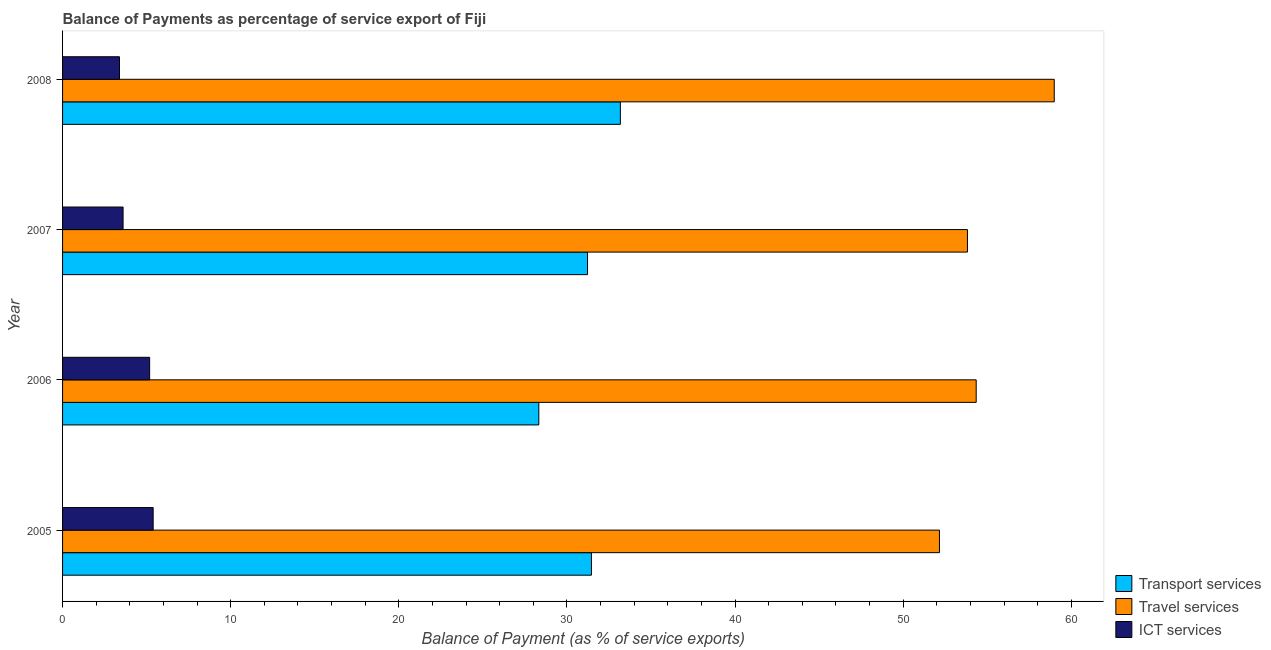How many different coloured bars are there?
Ensure brevity in your answer.  3. How many groups of bars are there?
Make the answer very short. 4. Are the number of bars per tick equal to the number of legend labels?
Provide a succinct answer. Yes. Are the number of bars on each tick of the Y-axis equal?
Offer a very short reply. Yes. What is the label of the 3rd group of bars from the top?
Your answer should be compact. 2006. In how many cases, is the number of bars for a given year not equal to the number of legend labels?
Keep it short and to the point. 0. What is the balance of payment of travel services in 2008?
Give a very brief answer. 58.98. Across all years, what is the maximum balance of payment of ict services?
Give a very brief answer. 5.39. Across all years, what is the minimum balance of payment of ict services?
Your response must be concise. 3.39. In which year was the balance of payment of travel services maximum?
Give a very brief answer. 2008. What is the total balance of payment of transport services in the graph?
Provide a short and direct response. 124.18. What is the difference between the balance of payment of transport services in 2005 and that in 2008?
Provide a succinct answer. -1.72. What is the difference between the balance of payment of transport services in 2006 and the balance of payment of ict services in 2008?
Make the answer very short. 24.94. What is the average balance of payment of ict services per year?
Your answer should be very brief. 4.39. In the year 2006, what is the difference between the balance of payment of travel services and balance of payment of ict services?
Provide a short and direct response. 49.16. In how many years, is the balance of payment of ict services greater than 32 %?
Your answer should be very brief. 0. What is the ratio of the balance of payment of transport services in 2005 to that in 2006?
Your answer should be compact. 1.11. Is the difference between the balance of payment of travel services in 2005 and 2007 greater than the difference between the balance of payment of ict services in 2005 and 2007?
Make the answer very short. No. What is the difference between the highest and the second highest balance of payment of ict services?
Your answer should be very brief. 0.21. What is the difference between the highest and the lowest balance of payment of travel services?
Keep it short and to the point. 6.83. In how many years, is the balance of payment of transport services greater than the average balance of payment of transport services taken over all years?
Offer a terse response. 3. Is the sum of the balance of payment of ict services in 2006 and 2008 greater than the maximum balance of payment of transport services across all years?
Make the answer very short. No. What does the 1st bar from the top in 2005 represents?
Keep it short and to the point. ICT services. What does the 2nd bar from the bottom in 2006 represents?
Offer a very short reply. Travel services. How many bars are there?
Offer a terse response. 12. Are all the bars in the graph horizontal?
Your answer should be compact. Yes. How many years are there in the graph?
Give a very brief answer. 4. Are the values on the major ticks of X-axis written in scientific E-notation?
Provide a succinct answer. No. Where does the legend appear in the graph?
Make the answer very short. Bottom right. How many legend labels are there?
Give a very brief answer. 3. What is the title of the graph?
Your answer should be compact. Balance of Payments as percentage of service export of Fiji. What is the label or title of the X-axis?
Provide a short and direct response. Balance of Payment (as % of service exports). What is the label or title of the Y-axis?
Keep it short and to the point. Year. What is the Balance of Payment (as % of service exports) in Transport services in 2005?
Offer a terse response. 31.45. What is the Balance of Payment (as % of service exports) of Travel services in 2005?
Your response must be concise. 52.15. What is the Balance of Payment (as % of service exports) of ICT services in 2005?
Keep it short and to the point. 5.39. What is the Balance of Payment (as % of service exports) in Transport services in 2006?
Keep it short and to the point. 28.33. What is the Balance of Payment (as % of service exports) of Travel services in 2006?
Offer a very short reply. 54.34. What is the Balance of Payment (as % of service exports) of ICT services in 2006?
Keep it short and to the point. 5.18. What is the Balance of Payment (as % of service exports) in Transport services in 2007?
Give a very brief answer. 31.22. What is the Balance of Payment (as % of service exports) of Travel services in 2007?
Keep it short and to the point. 53.82. What is the Balance of Payment (as % of service exports) in ICT services in 2007?
Ensure brevity in your answer.  3.6. What is the Balance of Payment (as % of service exports) of Transport services in 2008?
Make the answer very short. 33.18. What is the Balance of Payment (as % of service exports) of Travel services in 2008?
Your response must be concise. 58.98. What is the Balance of Payment (as % of service exports) in ICT services in 2008?
Make the answer very short. 3.39. Across all years, what is the maximum Balance of Payment (as % of service exports) in Transport services?
Keep it short and to the point. 33.18. Across all years, what is the maximum Balance of Payment (as % of service exports) in Travel services?
Your answer should be compact. 58.98. Across all years, what is the maximum Balance of Payment (as % of service exports) of ICT services?
Provide a succinct answer. 5.39. Across all years, what is the minimum Balance of Payment (as % of service exports) of Transport services?
Give a very brief answer. 28.33. Across all years, what is the minimum Balance of Payment (as % of service exports) in Travel services?
Make the answer very short. 52.15. Across all years, what is the minimum Balance of Payment (as % of service exports) of ICT services?
Your answer should be compact. 3.39. What is the total Balance of Payment (as % of service exports) of Transport services in the graph?
Give a very brief answer. 124.18. What is the total Balance of Payment (as % of service exports) of Travel services in the graph?
Ensure brevity in your answer.  219.3. What is the total Balance of Payment (as % of service exports) in ICT services in the graph?
Your answer should be very brief. 17.55. What is the difference between the Balance of Payment (as % of service exports) in Transport services in 2005 and that in 2006?
Your answer should be very brief. 3.13. What is the difference between the Balance of Payment (as % of service exports) in Travel services in 2005 and that in 2006?
Offer a very short reply. -2.18. What is the difference between the Balance of Payment (as % of service exports) in ICT services in 2005 and that in 2006?
Your response must be concise. 0.21. What is the difference between the Balance of Payment (as % of service exports) in Transport services in 2005 and that in 2007?
Your answer should be very brief. 0.23. What is the difference between the Balance of Payment (as % of service exports) in Travel services in 2005 and that in 2007?
Give a very brief answer. -1.66. What is the difference between the Balance of Payment (as % of service exports) in ICT services in 2005 and that in 2007?
Make the answer very short. 1.79. What is the difference between the Balance of Payment (as % of service exports) of Transport services in 2005 and that in 2008?
Give a very brief answer. -1.72. What is the difference between the Balance of Payment (as % of service exports) in Travel services in 2005 and that in 2008?
Your response must be concise. -6.83. What is the difference between the Balance of Payment (as % of service exports) in ICT services in 2005 and that in 2008?
Provide a short and direct response. 2. What is the difference between the Balance of Payment (as % of service exports) of Transport services in 2006 and that in 2007?
Give a very brief answer. -2.9. What is the difference between the Balance of Payment (as % of service exports) in Travel services in 2006 and that in 2007?
Offer a very short reply. 0.52. What is the difference between the Balance of Payment (as % of service exports) in ICT services in 2006 and that in 2007?
Make the answer very short. 1.58. What is the difference between the Balance of Payment (as % of service exports) in Transport services in 2006 and that in 2008?
Give a very brief answer. -4.85. What is the difference between the Balance of Payment (as % of service exports) in Travel services in 2006 and that in 2008?
Keep it short and to the point. -4.64. What is the difference between the Balance of Payment (as % of service exports) of ICT services in 2006 and that in 2008?
Keep it short and to the point. 1.79. What is the difference between the Balance of Payment (as % of service exports) in Transport services in 2007 and that in 2008?
Your response must be concise. -1.95. What is the difference between the Balance of Payment (as % of service exports) in Travel services in 2007 and that in 2008?
Your answer should be compact. -5.16. What is the difference between the Balance of Payment (as % of service exports) of ICT services in 2007 and that in 2008?
Your response must be concise. 0.21. What is the difference between the Balance of Payment (as % of service exports) of Transport services in 2005 and the Balance of Payment (as % of service exports) of Travel services in 2006?
Offer a very short reply. -22.88. What is the difference between the Balance of Payment (as % of service exports) of Transport services in 2005 and the Balance of Payment (as % of service exports) of ICT services in 2006?
Ensure brevity in your answer.  26.28. What is the difference between the Balance of Payment (as % of service exports) of Travel services in 2005 and the Balance of Payment (as % of service exports) of ICT services in 2006?
Provide a short and direct response. 46.98. What is the difference between the Balance of Payment (as % of service exports) of Transport services in 2005 and the Balance of Payment (as % of service exports) of Travel services in 2007?
Your response must be concise. -22.37. What is the difference between the Balance of Payment (as % of service exports) in Transport services in 2005 and the Balance of Payment (as % of service exports) in ICT services in 2007?
Provide a succinct answer. 27.86. What is the difference between the Balance of Payment (as % of service exports) of Travel services in 2005 and the Balance of Payment (as % of service exports) of ICT services in 2007?
Your answer should be very brief. 48.56. What is the difference between the Balance of Payment (as % of service exports) in Transport services in 2005 and the Balance of Payment (as % of service exports) in Travel services in 2008?
Ensure brevity in your answer.  -27.53. What is the difference between the Balance of Payment (as % of service exports) of Transport services in 2005 and the Balance of Payment (as % of service exports) of ICT services in 2008?
Your answer should be compact. 28.07. What is the difference between the Balance of Payment (as % of service exports) of Travel services in 2005 and the Balance of Payment (as % of service exports) of ICT services in 2008?
Your answer should be compact. 48.77. What is the difference between the Balance of Payment (as % of service exports) in Transport services in 2006 and the Balance of Payment (as % of service exports) in Travel services in 2007?
Offer a very short reply. -25.49. What is the difference between the Balance of Payment (as % of service exports) of Transport services in 2006 and the Balance of Payment (as % of service exports) of ICT services in 2007?
Offer a terse response. 24.73. What is the difference between the Balance of Payment (as % of service exports) of Travel services in 2006 and the Balance of Payment (as % of service exports) of ICT services in 2007?
Your response must be concise. 50.74. What is the difference between the Balance of Payment (as % of service exports) in Transport services in 2006 and the Balance of Payment (as % of service exports) in Travel services in 2008?
Make the answer very short. -30.66. What is the difference between the Balance of Payment (as % of service exports) in Transport services in 2006 and the Balance of Payment (as % of service exports) in ICT services in 2008?
Provide a succinct answer. 24.94. What is the difference between the Balance of Payment (as % of service exports) of Travel services in 2006 and the Balance of Payment (as % of service exports) of ICT services in 2008?
Offer a terse response. 50.95. What is the difference between the Balance of Payment (as % of service exports) in Transport services in 2007 and the Balance of Payment (as % of service exports) in Travel services in 2008?
Provide a succinct answer. -27.76. What is the difference between the Balance of Payment (as % of service exports) in Transport services in 2007 and the Balance of Payment (as % of service exports) in ICT services in 2008?
Offer a very short reply. 27.84. What is the difference between the Balance of Payment (as % of service exports) of Travel services in 2007 and the Balance of Payment (as % of service exports) of ICT services in 2008?
Give a very brief answer. 50.43. What is the average Balance of Payment (as % of service exports) of Transport services per year?
Ensure brevity in your answer.  31.04. What is the average Balance of Payment (as % of service exports) of Travel services per year?
Provide a succinct answer. 54.82. What is the average Balance of Payment (as % of service exports) of ICT services per year?
Your response must be concise. 4.39. In the year 2005, what is the difference between the Balance of Payment (as % of service exports) in Transport services and Balance of Payment (as % of service exports) in Travel services?
Your answer should be compact. -20.7. In the year 2005, what is the difference between the Balance of Payment (as % of service exports) in Transport services and Balance of Payment (as % of service exports) in ICT services?
Provide a short and direct response. 26.07. In the year 2005, what is the difference between the Balance of Payment (as % of service exports) in Travel services and Balance of Payment (as % of service exports) in ICT services?
Provide a short and direct response. 46.77. In the year 2006, what is the difference between the Balance of Payment (as % of service exports) of Transport services and Balance of Payment (as % of service exports) of Travel services?
Provide a succinct answer. -26.01. In the year 2006, what is the difference between the Balance of Payment (as % of service exports) in Transport services and Balance of Payment (as % of service exports) in ICT services?
Offer a terse response. 23.15. In the year 2006, what is the difference between the Balance of Payment (as % of service exports) in Travel services and Balance of Payment (as % of service exports) in ICT services?
Your answer should be very brief. 49.16. In the year 2007, what is the difference between the Balance of Payment (as % of service exports) in Transport services and Balance of Payment (as % of service exports) in Travel services?
Provide a short and direct response. -22.6. In the year 2007, what is the difference between the Balance of Payment (as % of service exports) of Transport services and Balance of Payment (as % of service exports) of ICT services?
Keep it short and to the point. 27.62. In the year 2007, what is the difference between the Balance of Payment (as % of service exports) in Travel services and Balance of Payment (as % of service exports) in ICT services?
Ensure brevity in your answer.  50.22. In the year 2008, what is the difference between the Balance of Payment (as % of service exports) in Transport services and Balance of Payment (as % of service exports) in Travel services?
Offer a very short reply. -25.81. In the year 2008, what is the difference between the Balance of Payment (as % of service exports) of Transport services and Balance of Payment (as % of service exports) of ICT services?
Offer a very short reply. 29.79. In the year 2008, what is the difference between the Balance of Payment (as % of service exports) of Travel services and Balance of Payment (as % of service exports) of ICT services?
Your response must be concise. 55.6. What is the ratio of the Balance of Payment (as % of service exports) in Transport services in 2005 to that in 2006?
Offer a very short reply. 1.11. What is the ratio of the Balance of Payment (as % of service exports) in Travel services in 2005 to that in 2006?
Provide a succinct answer. 0.96. What is the ratio of the Balance of Payment (as % of service exports) of ICT services in 2005 to that in 2006?
Your response must be concise. 1.04. What is the ratio of the Balance of Payment (as % of service exports) of Transport services in 2005 to that in 2007?
Offer a very short reply. 1.01. What is the ratio of the Balance of Payment (as % of service exports) in Travel services in 2005 to that in 2007?
Your answer should be compact. 0.97. What is the ratio of the Balance of Payment (as % of service exports) of ICT services in 2005 to that in 2007?
Your answer should be compact. 1.5. What is the ratio of the Balance of Payment (as % of service exports) of Transport services in 2005 to that in 2008?
Your answer should be very brief. 0.95. What is the ratio of the Balance of Payment (as % of service exports) of Travel services in 2005 to that in 2008?
Your answer should be compact. 0.88. What is the ratio of the Balance of Payment (as % of service exports) in ICT services in 2005 to that in 2008?
Keep it short and to the point. 1.59. What is the ratio of the Balance of Payment (as % of service exports) in Transport services in 2006 to that in 2007?
Your response must be concise. 0.91. What is the ratio of the Balance of Payment (as % of service exports) in Travel services in 2006 to that in 2007?
Provide a succinct answer. 1.01. What is the ratio of the Balance of Payment (as % of service exports) in ICT services in 2006 to that in 2007?
Offer a very short reply. 1.44. What is the ratio of the Balance of Payment (as % of service exports) in Transport services in 2006 to that in 2008?
Offer a very short reply. 0.85. What is the ratio of the Balance of Payment (as % of service exports) in Travel services in 2006 to that in 2008?
Provide a succinct answer. 0.92. What is the ratio of the Balance of Payment (as % of service exports) of ICT services in 2006 to that in 2008?
Your answer should be compact. 1.53. What is the ratio of the Balance of Payment (as % of service exports) in Transport services in 2007 to that in 2008?
Provide a short and direct response. 0.94. What is the ratio of the Balance of Payment (as % of service exports) of Travel services in 2007 to that in 2008?
Give a very brief answer. 0.91. What is the ratio of the Balance of Payment (as % of service exports) of ICT services in 2007 to that in 2008?
Make the answer very short. 1.06. What is the difference between the highest and the second highest Balance of Payment (as % of service exports) of Transport services?
Offer a very short reply. 1.72. What is the difference between the highest and the second highest Balance of Payment (as % of service exports) in Travel services?
Ensure brevity in your answer.  4.64. What is the difference between the highest and the second highest Balance of Payment (as % of service exports) of ICT services?
Offer a very short reply. 0.21. What is the difference between the highest and the lowest Balance of Payment (as % of service exports) of Transport services?
Keep it short and to the point. 4.85. What is the difference between the highest and the lowest Balance of Payment (as % of service exports) in Travel services?
Your answer should be very brief. 6.83. What is the difference between the highest and the lowest Balance of Payment (as % of service exports) of ICT services?
Ensure brevity in your answer.  2. 